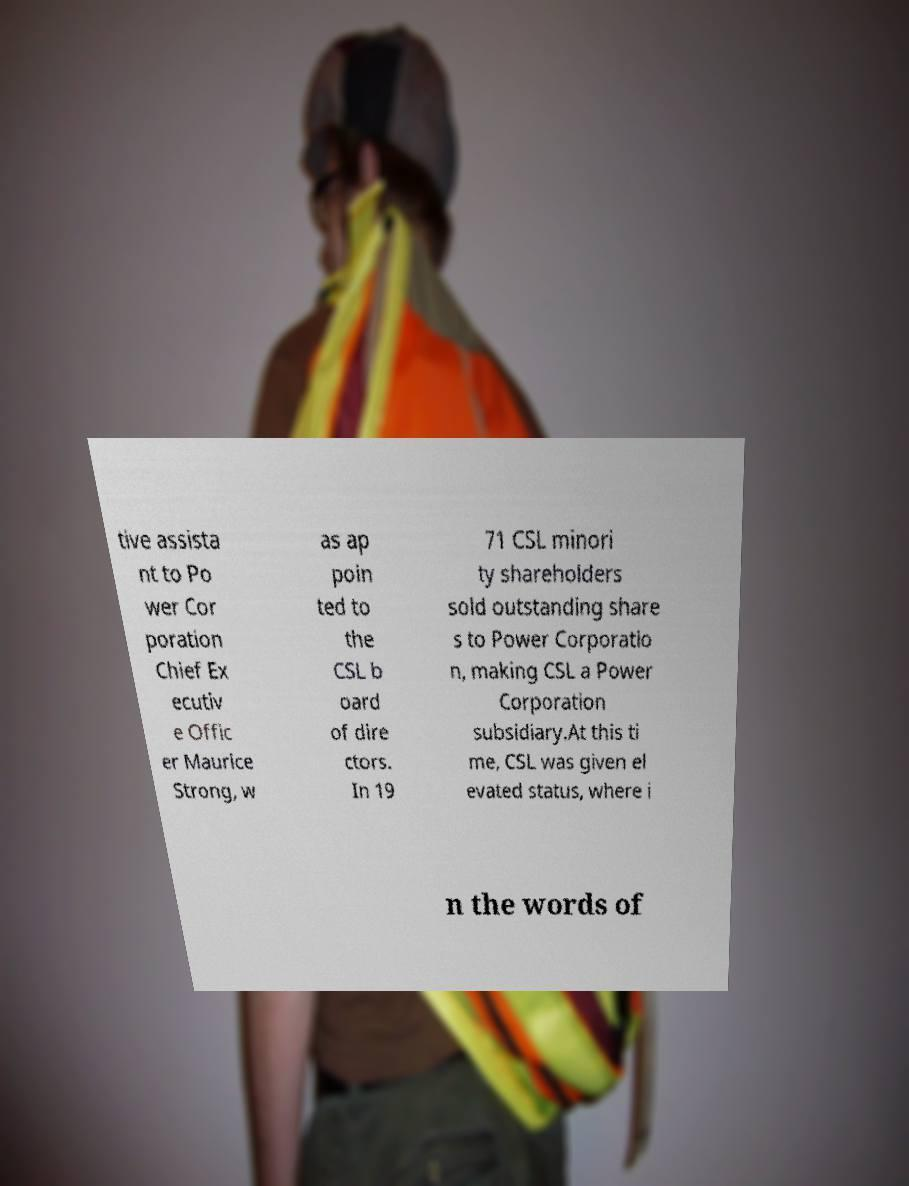Please read and relay the text visible in this image. What does it say? tive assista nt to Po wer Cor poration Chief Ex ecutiv e Offic er Maurice Strong, w as ap poin ted to the CSL b oard of dire ctors. In 19 71 CSL minori ty shareholders sold outstanding share s to Power Corporatio n, making CSL a Power Corporation subsidiary.At this ti me, CSL was given el evated status, where i n the words of 